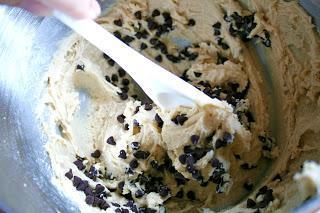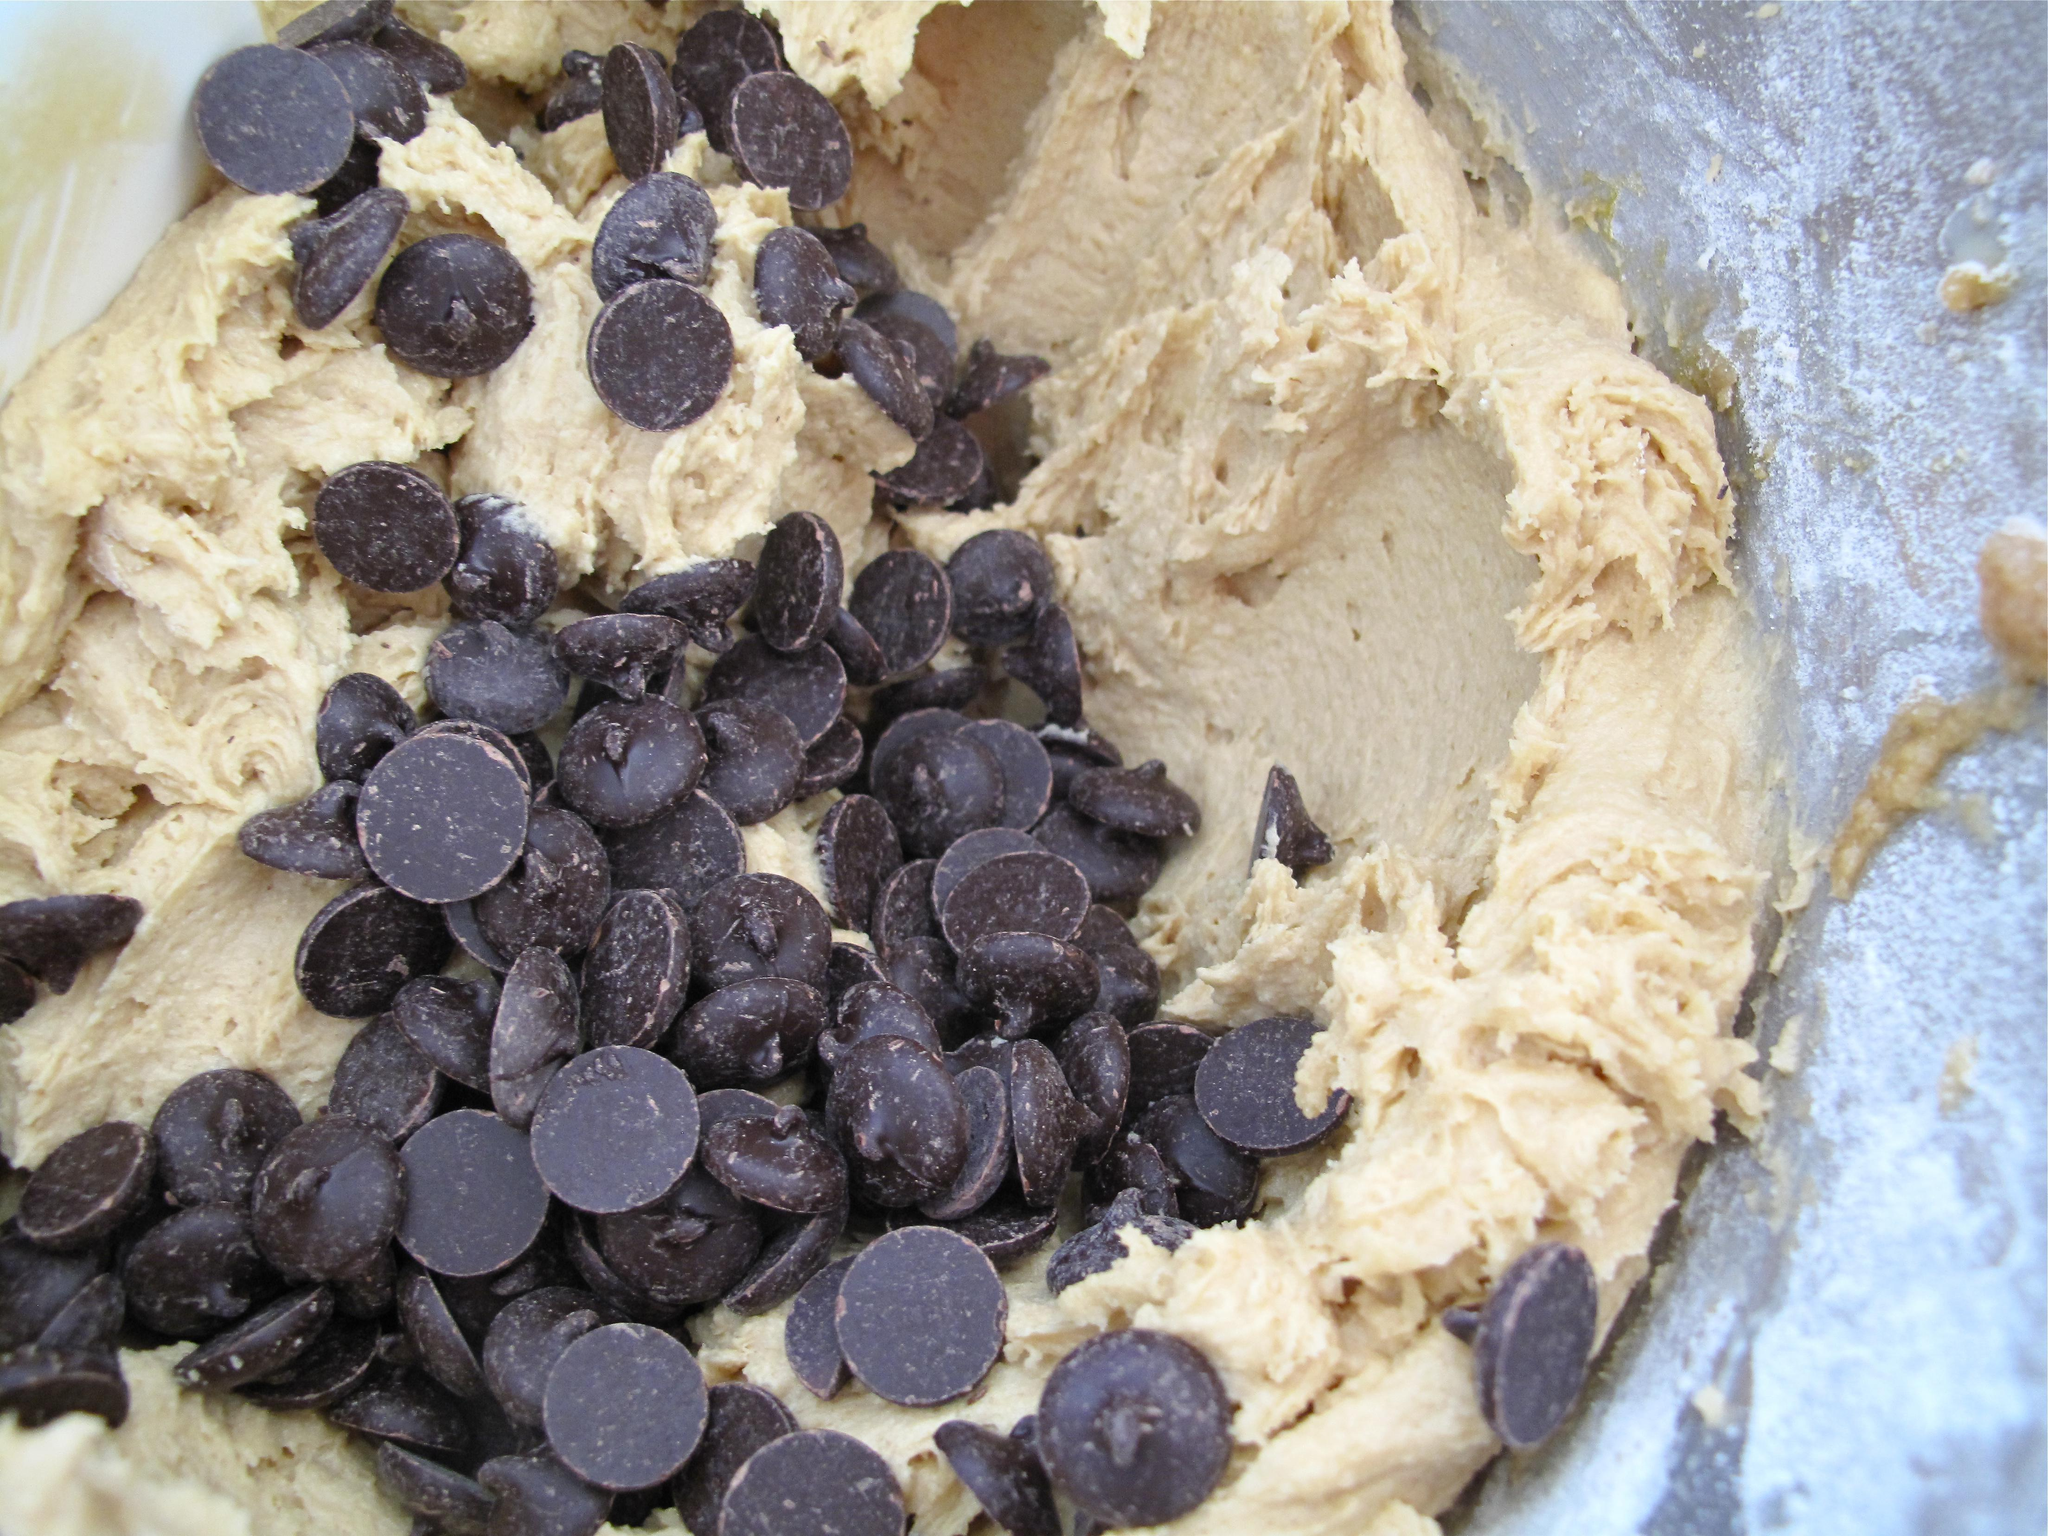The first image is the image on the left, the second image is the image on the right. Considering the images on both sides, is "The image on the right contains a bowl of cookie dough with a wooden spoon in it." valid? Answer yes or no. No. The first image is the image on the left, the second image is the image on the right. Examine the images to the left and right. Is the description "Both images show unfinished cookie dough with chocolate chips." accurate? Answer yes or no. Yes. 